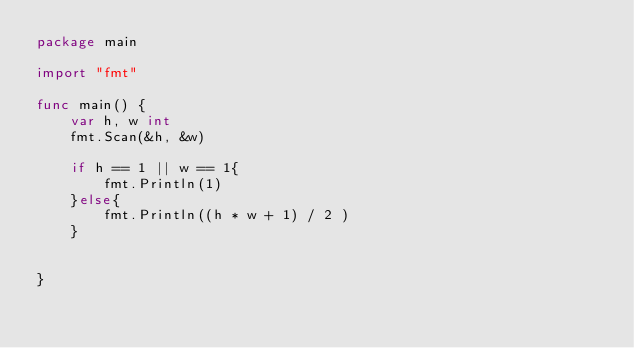Convert code to text. <code><loc_0><loc_0><loc_500><loc_500><_Go_>package main

import "fmt"

func main() {
	var h, w int
	fmt.Scan(&h, &w)

	if h == 1 || w == 1{
		fmt.Println(1)
	}else{
		fmt.Println((h * w + 1) / 2 )
	}


}</code> 